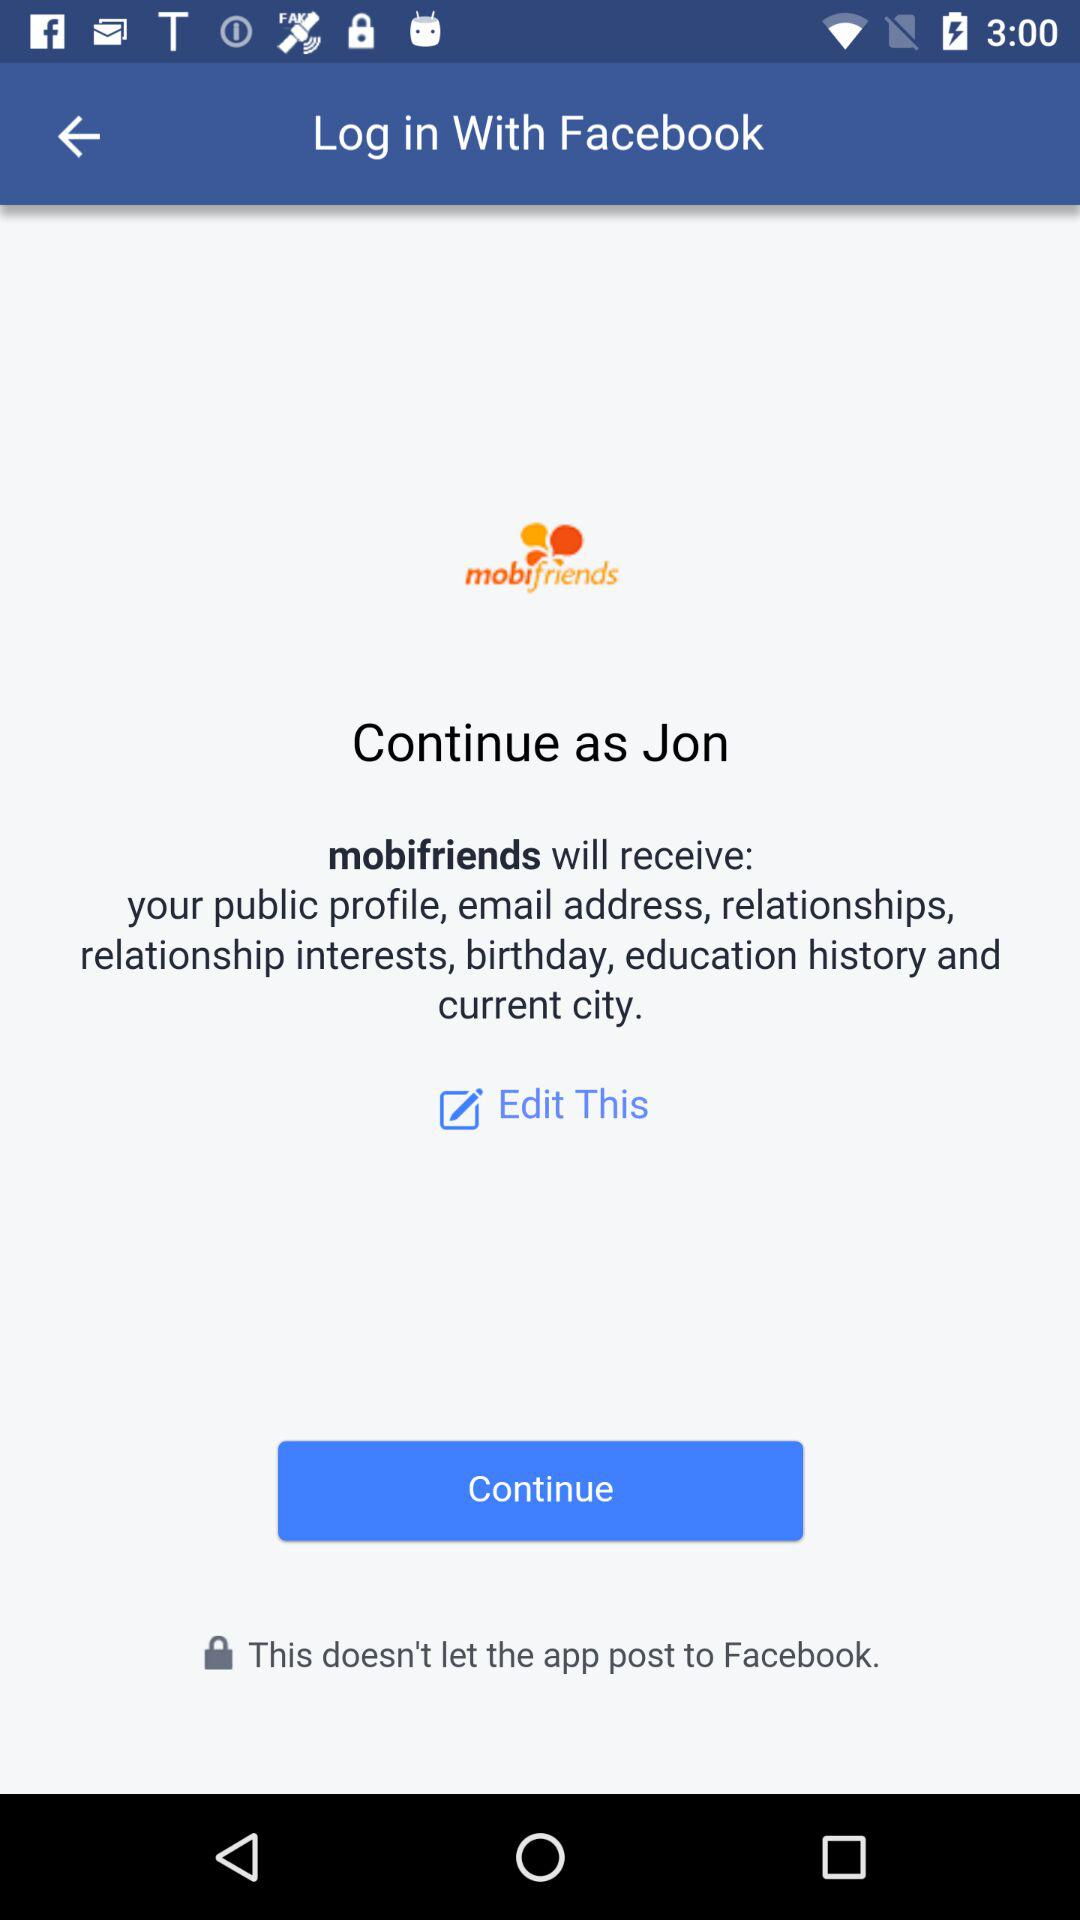Through which application is the person logging in? The person is logging in through "Facebook". 